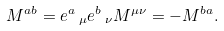Convert formula to latex. <formula><loc_0><loc_0><loc_500><loc_500>M ^ { a b } = e ^ { a } \, _ { \mu } e ^ { b } \, _ { \nu } M ^ { \mu \nu } = - M ^ { b a } .</formula> 